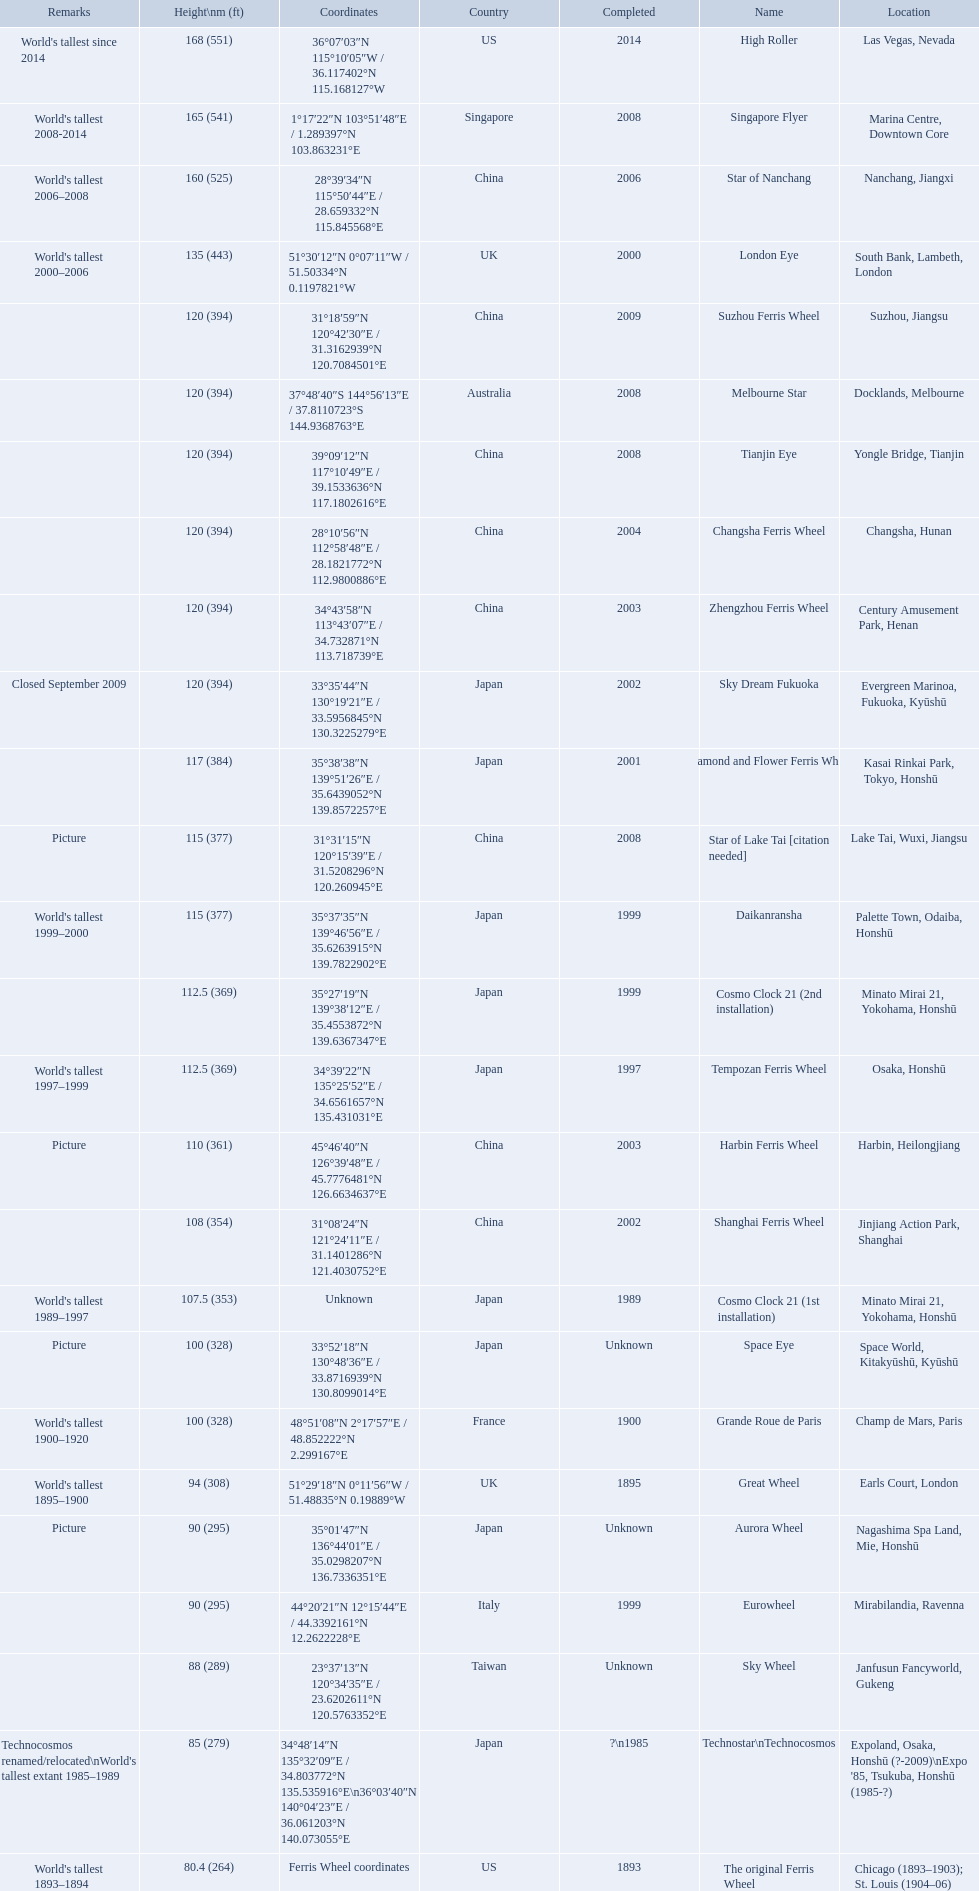How tall is the roller coaster star of nanchang? 165 (541). When was the roller coaster star of nanchang completed? 2008. What is the name of the oldest roller coaster? Star of Nanchang. 